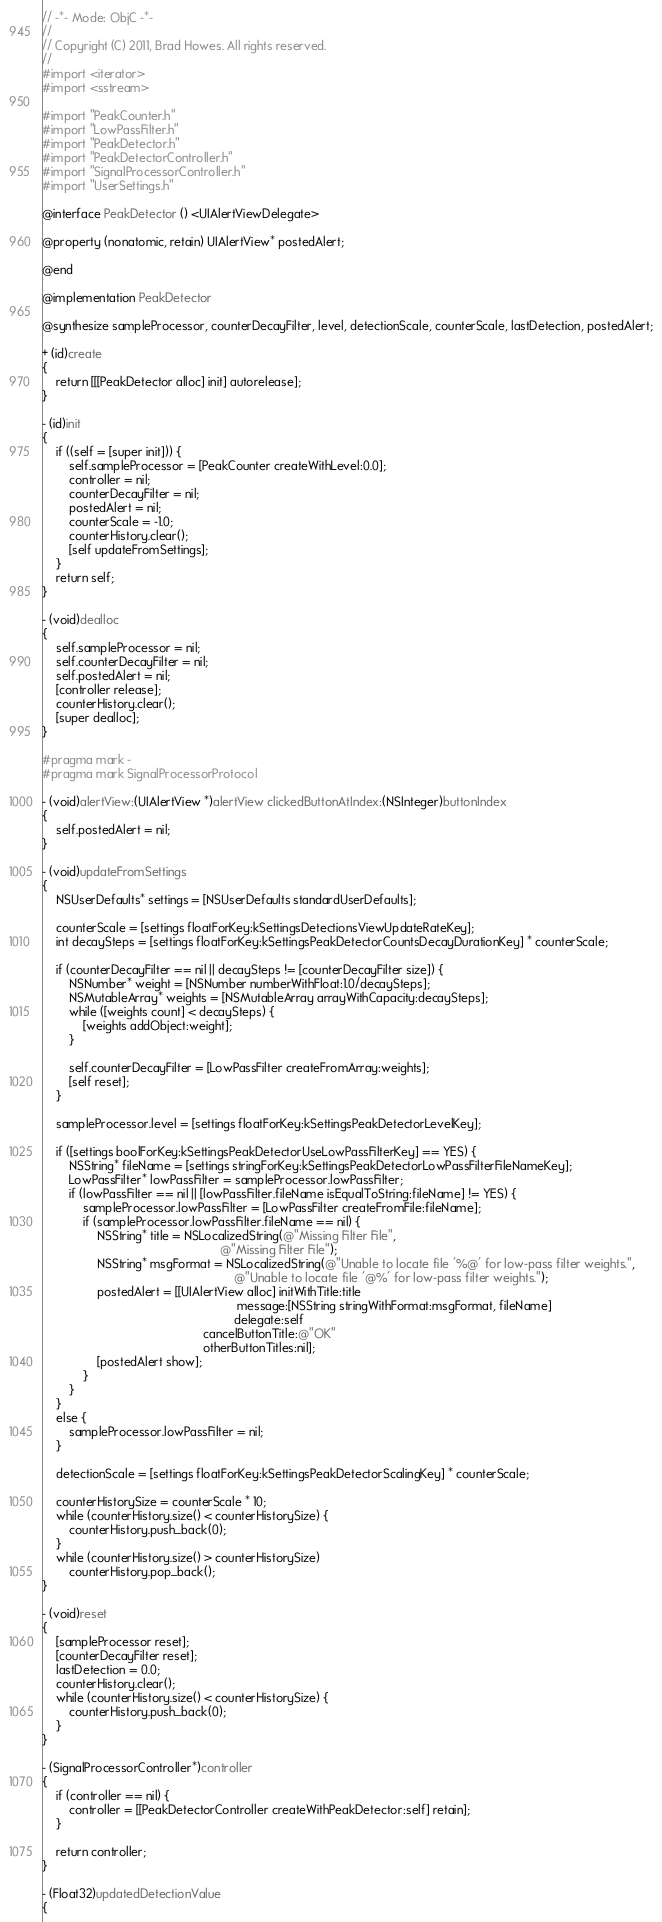Convert code to text. <code><loc_0><loc_0><loc_500><loc_500><_ObjectiveC_>// -*- Mode: ObjC -*-
//
// Copyright (C) 2011, Brad Howes. All rights reserved.
//
#import <iterator>
#import <sstream>

#import "PeakCounter.h"
#import "LowPassFilter.h"
#import "PeakDetector.h"
#import "PeakDetectorController.h"
#import "SignalProcessorController.h"
#import "UserSettings.h"

@interface PeakDetector () <UIAlertViewDelegate>

@property (nonatomic, retain) UIAlertView* postedAlert;

@end

@implementation PeakDetector

@synthesize sampleProcessor, counterDecayFilter, level, detectionScale, counterScale, lastDetection, postedAlert;

+ (id)create
{
    return [[[PeakDetector alloc] init] autorelease];
}

- (id)init
{
    if ((self = [super init])) {
        self.sampleProcessor = [PeakCounter createWithLevel:0.0];
        controller = nil;
        counterDecayFilter = nil;
        postedAlert = nil;
        counterScale = -1.0;
        counterHistory.clear();
        [self updateFromSettings];
    }
    return self;
}

- (void)dealloc
{
    self.sampleProcessor = nil;
    self.counterDecayFilter = nil;
    self.postedAlert = nil;
    [controller release];
    counterHistory.clear();
    [super dealloc];
}

#pragma mark -
#pragma mark SignalProcessorProtocol

- (void)alertView:(UIAlertView *)alertView clickedButtonAtIndex:(NSInteger)buttonIndex
{
    self.postedAlert = nil;
}

- (void)updateFromSettings
{
    NSUserDefaults* settings = [NSUserDefaults standardUserDefaults];
    
    counterScale = [settings floatForKey:kSettingsDetectionsViewUpdateRateKey];
    int decaySteps = [settings floatForKey:kSettingsPeakDetectorCountsDecayDurationKey] * counterScale;
    
    if (counterDecayFilter == nil || decaySteps != [counterDecayFilter size]) {
        NSNumber* weight = [NSNumber numberWithFloat:1.0/decaySteps];
        NSMutableArray* weights = [NSMutableArray arrayWithCapacity:decaySteps];
        while ([weights count] < decaySteps) {
            [weights addObject:weight];
        }
        
        self.counterDecayFilter = [LowPassFilter createFromArray:weights];
        [self reset];
    }
    
    sampleProcessor.level = [settings floatForKey:kSettingsPeakDetectorLevelKey];
    
    if ([settings boolForKey:kSettingsPeakDetectorUseLowPassFilterKey] == YES) {
        NSString* fileName = [settings stringForKey:kSettingsPeakDetectorLowPassFilterFileNameKey];
        LowPassFilter* lowPassFilter = sampleProcessor.lowPassFilter;
        if (lowPassFilter == nil || [lowPassFilter.fileName isEqualToString:fileName] != YES) {
            sampleProcessor.lowPassFilter = [LowPassFilter createFromFile:fileName];
            if (sampleProcessor.lowPassFilter.fileName == nil) {
                NSString* title = NSLocalizedString(@"Missing Filter File",
                                                    @"Missing Filter File");
                NSString* msgFormat = NSLocalizedString(@"Unable to locate file '%@' for low-pass filter weights.",
                                                        @"Unable to locate file '@%' for low-pass filter weights.");
                postedAlert = [[UIAlertView alloc] initWithTitle:title
                                                         message:[NSString stringWithFormat:msgFormat, fileName]
                                                        delegate:self
                                               cancelButtonTitle:@"OK"
                                               otherButtonTitles:nil];
                [postedAlert show];
            }
        }
    }
    else {
        sampleProcessor.lowPassFilter = nil;
    }
    
    detectionScale = [settings floatForKey:kSettingsPeakDetectorScalingKey] * counterScale;
    
    counterHistorySize = counterScale * 10;
    while (counterHistory.size() < counterHistorySize) {
        counterHistory.push_back(0);
    }
    while (counterHistory.size() > counterHistorySize)
        counterHistory.pop_back();
}

- (void)reset
{
    [sampleProcessor reset];
    [counterDecayFilter reset];
    lastDetection = 0.0;
    counterHistory.clear();
    while (counterHistory.size() < counterHistorySize) {
        counterHistory.push_back(0);
    }
}

- (SignalProcessorController*)controller
{
    if (controller == nil) {
        controller = [[PeakDetectorController createWithPeakDetector:self] retain];
    }
    
    return controller;
}

- (Float32)updatedDetectionValue
{</code> 